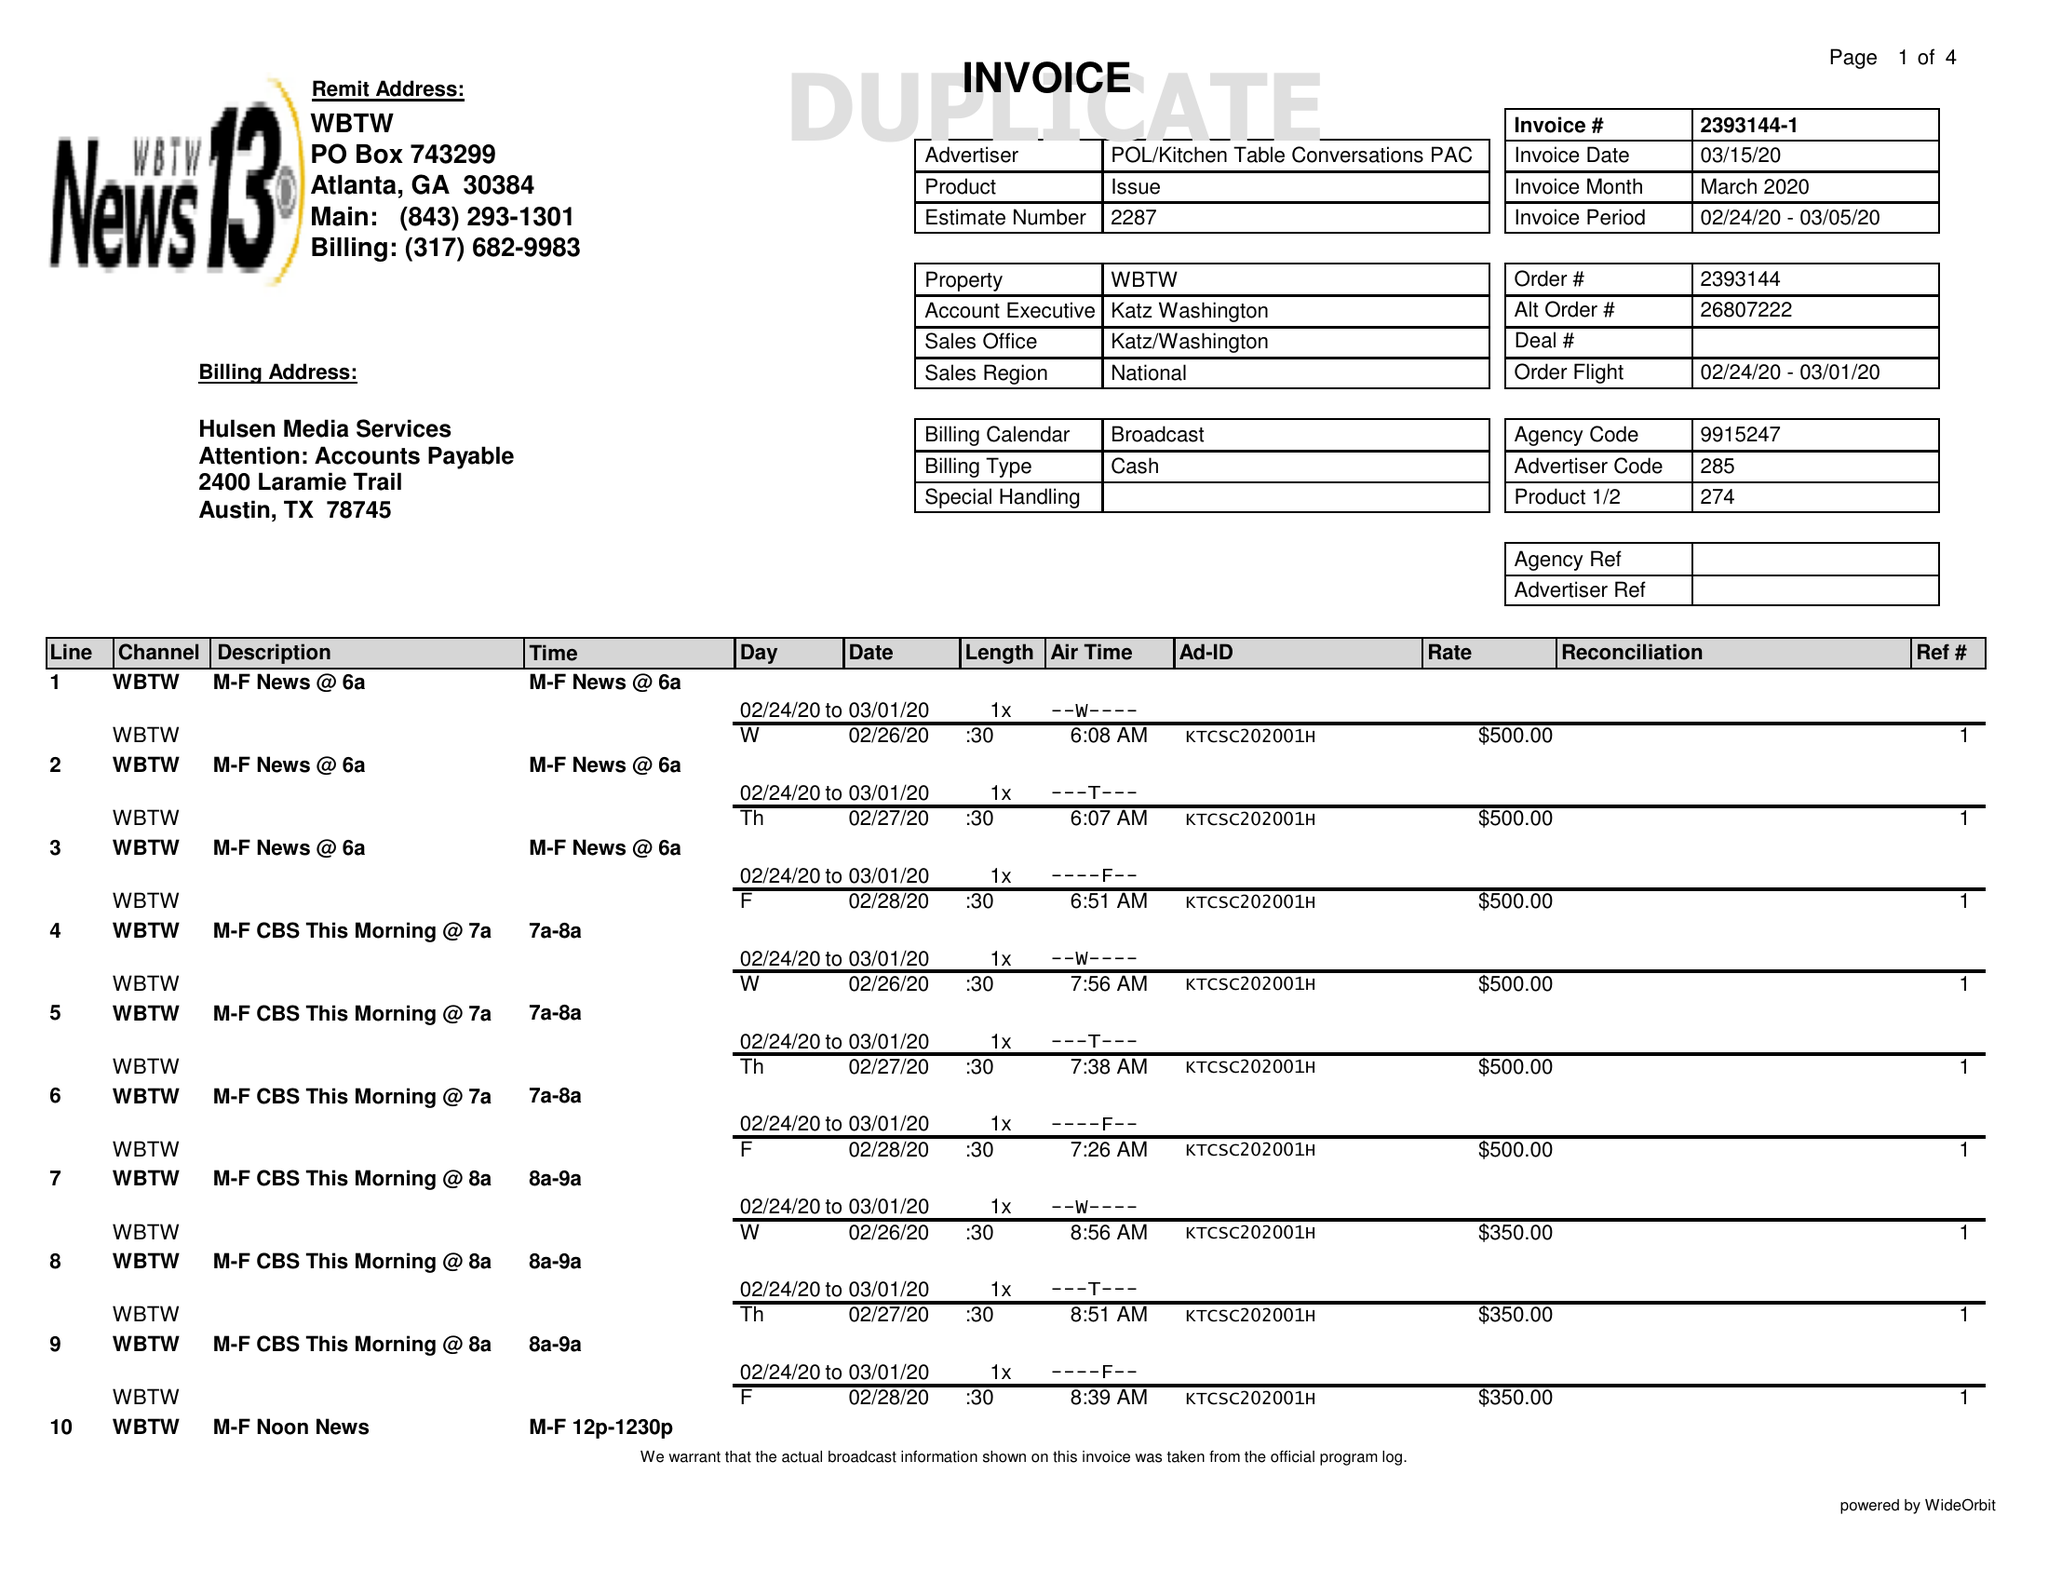What is the value for the flight_to?
Answer the question using a single word or phrase. 03/01/20 